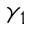Convert formula to latex. <formula><loc_0><loc_0><loc_500><loc_500>\gamma _ { 1 }</formula> 